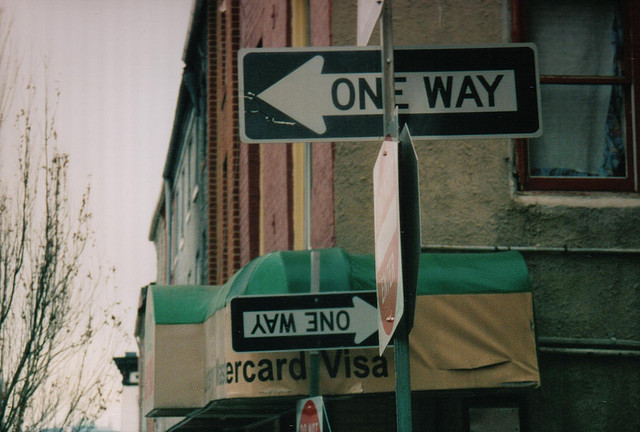Identify the text displayed in this image. ONE WAY WAY ONE Visa er card 